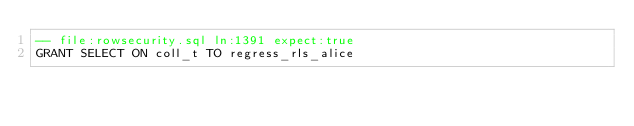Convert code to text. <code><loc_0><loc_0><loc_500><loc_500><_SQL_>-- file:rowsecurity.sql ln:1391 expect:true
GRANT SELECT ON coll_t TO regress_rls_alice
</code> 